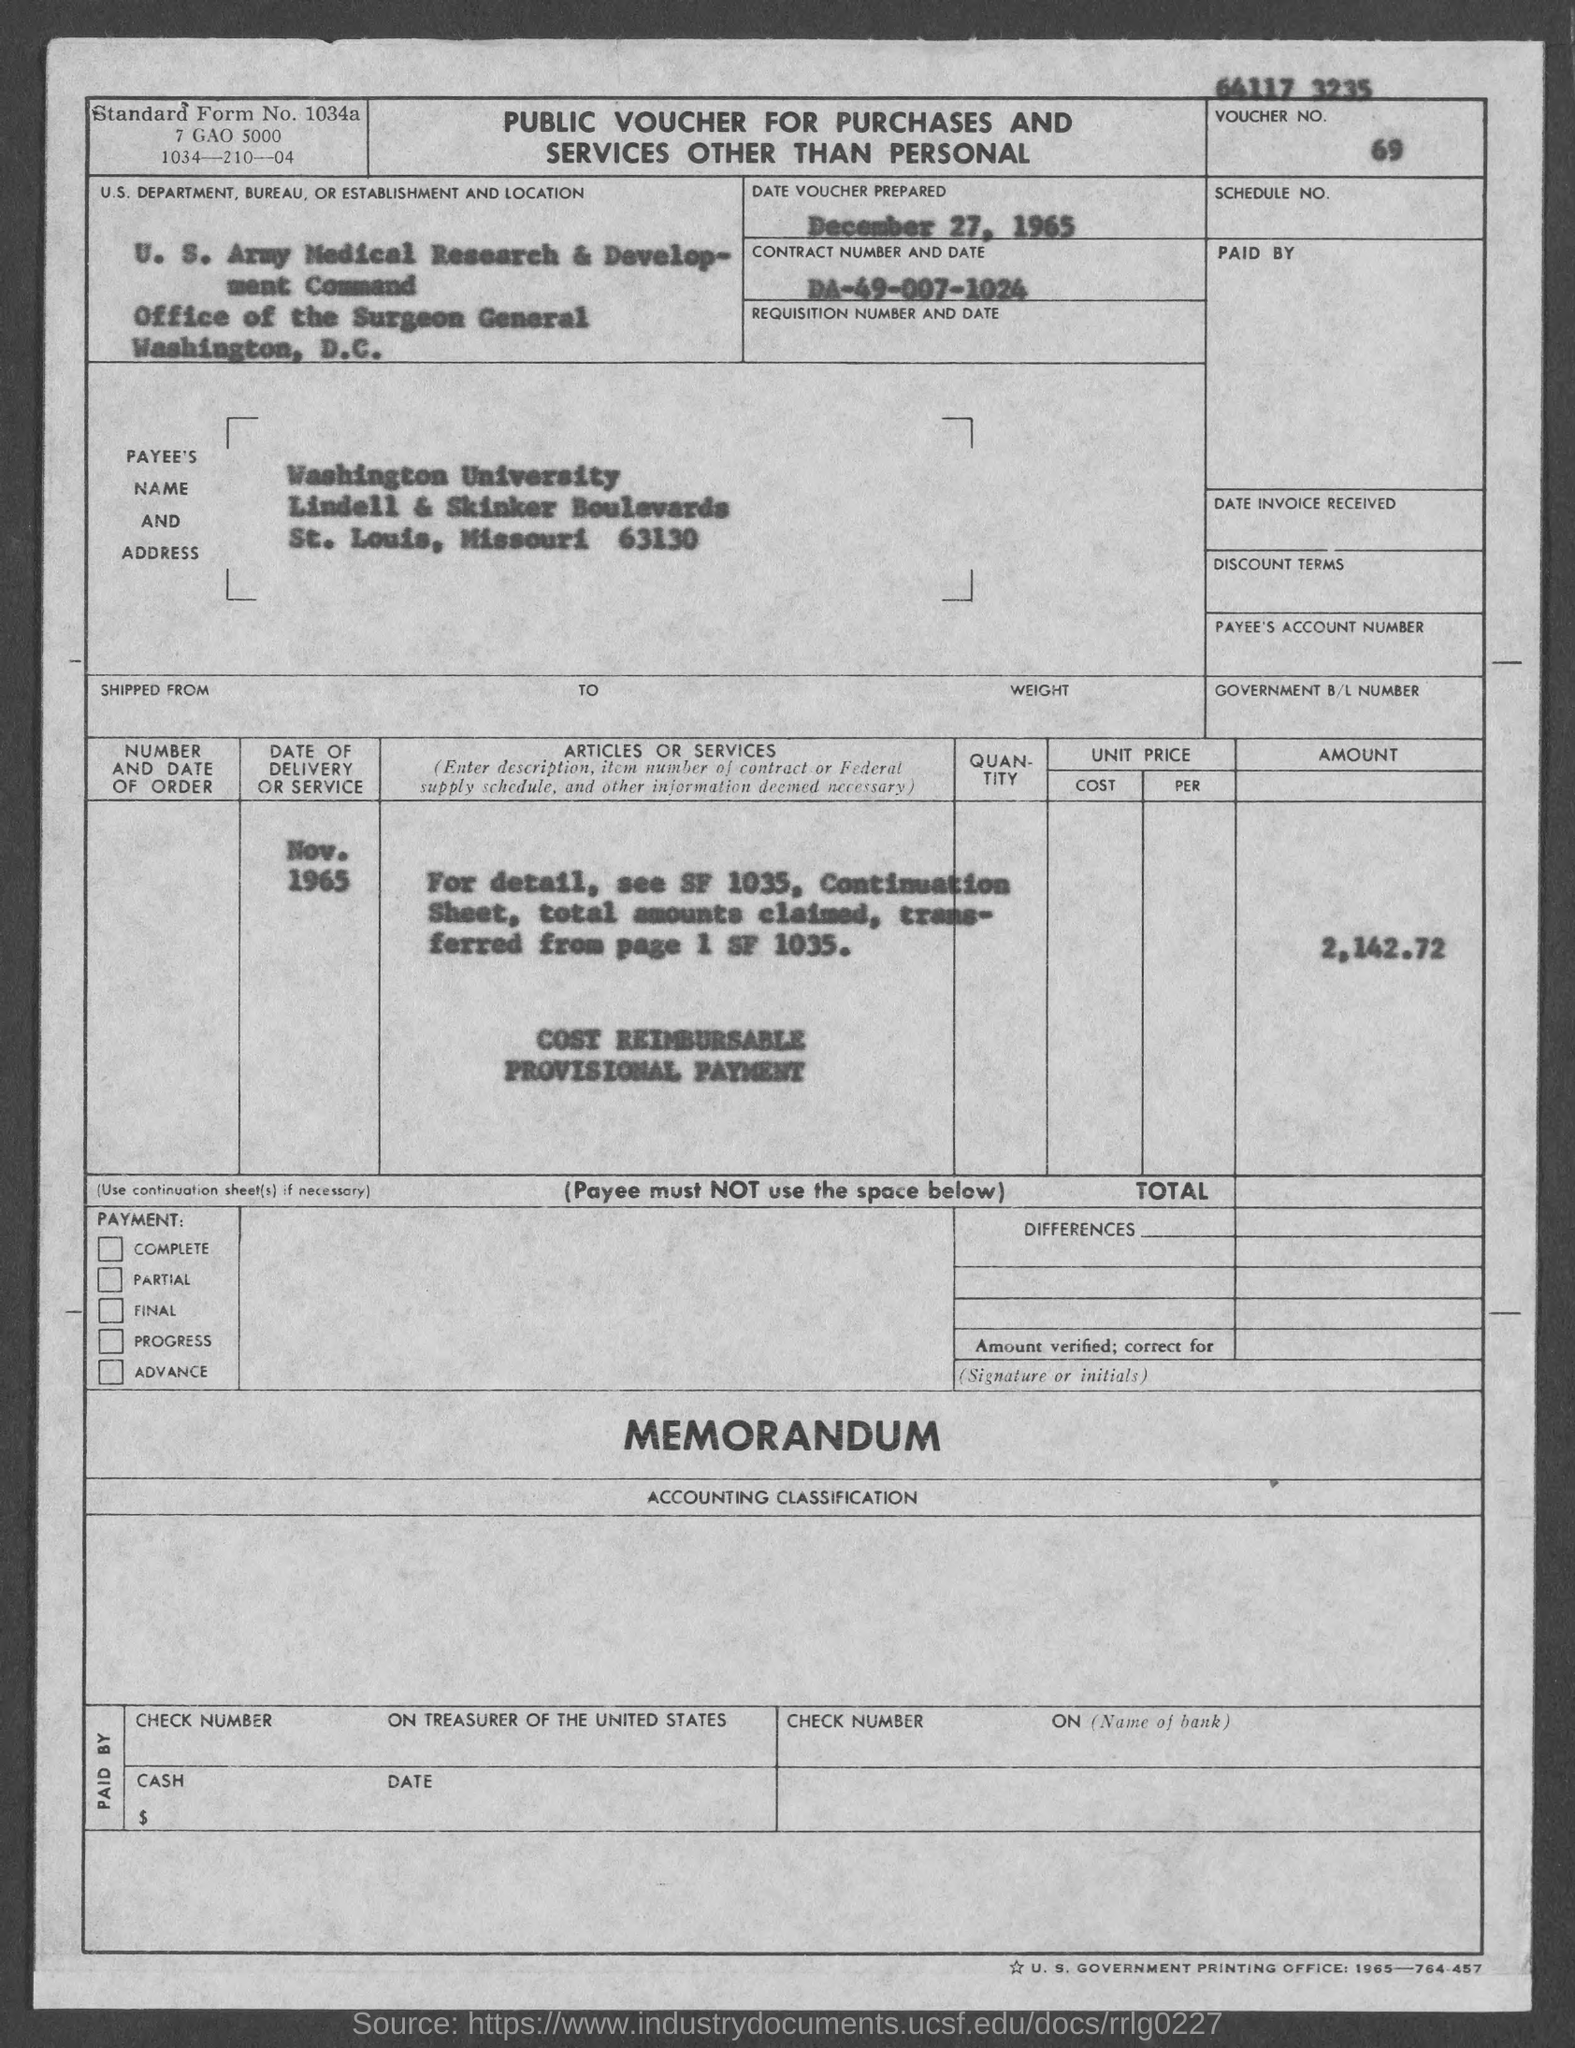Point out several critical features in this image. The U.S. Army Medical Research & Development Command is specified in the voucher. The voucher number provided in the document is 69... The total voucher amount mentioned in the document is 2,142.72. The date of the voucher was prepared on December 27, 1965. The payee name listed on the voucher is Washington University. 